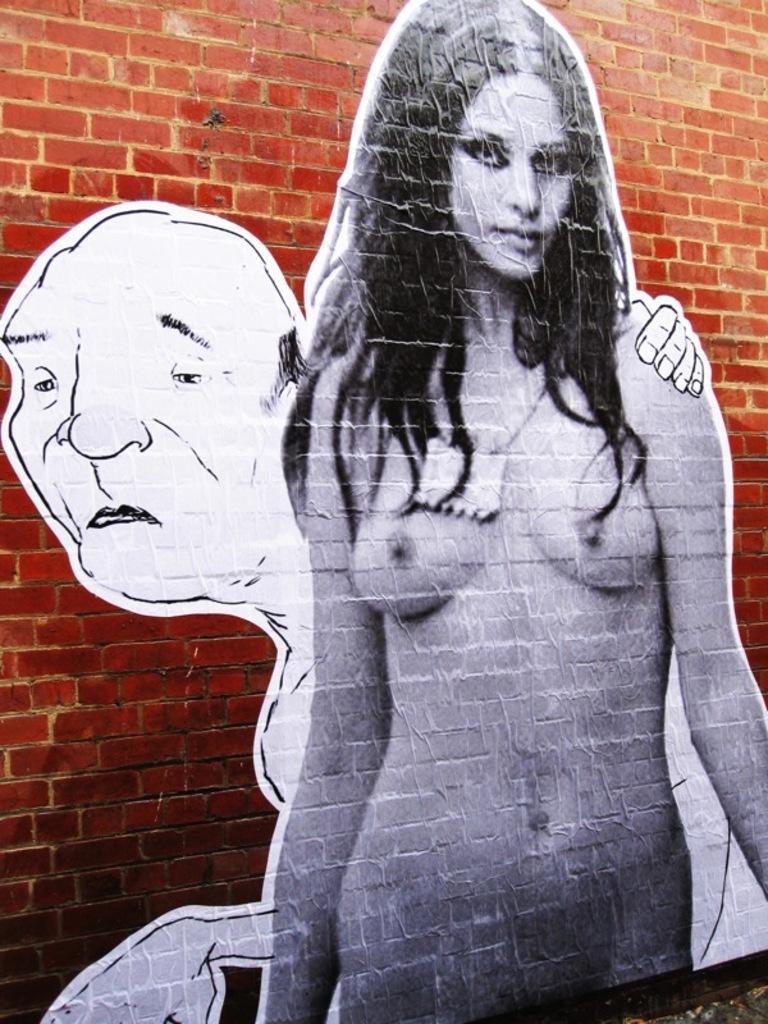Can you describe this image briefly? In this image, we can see posts of people on the wall. 